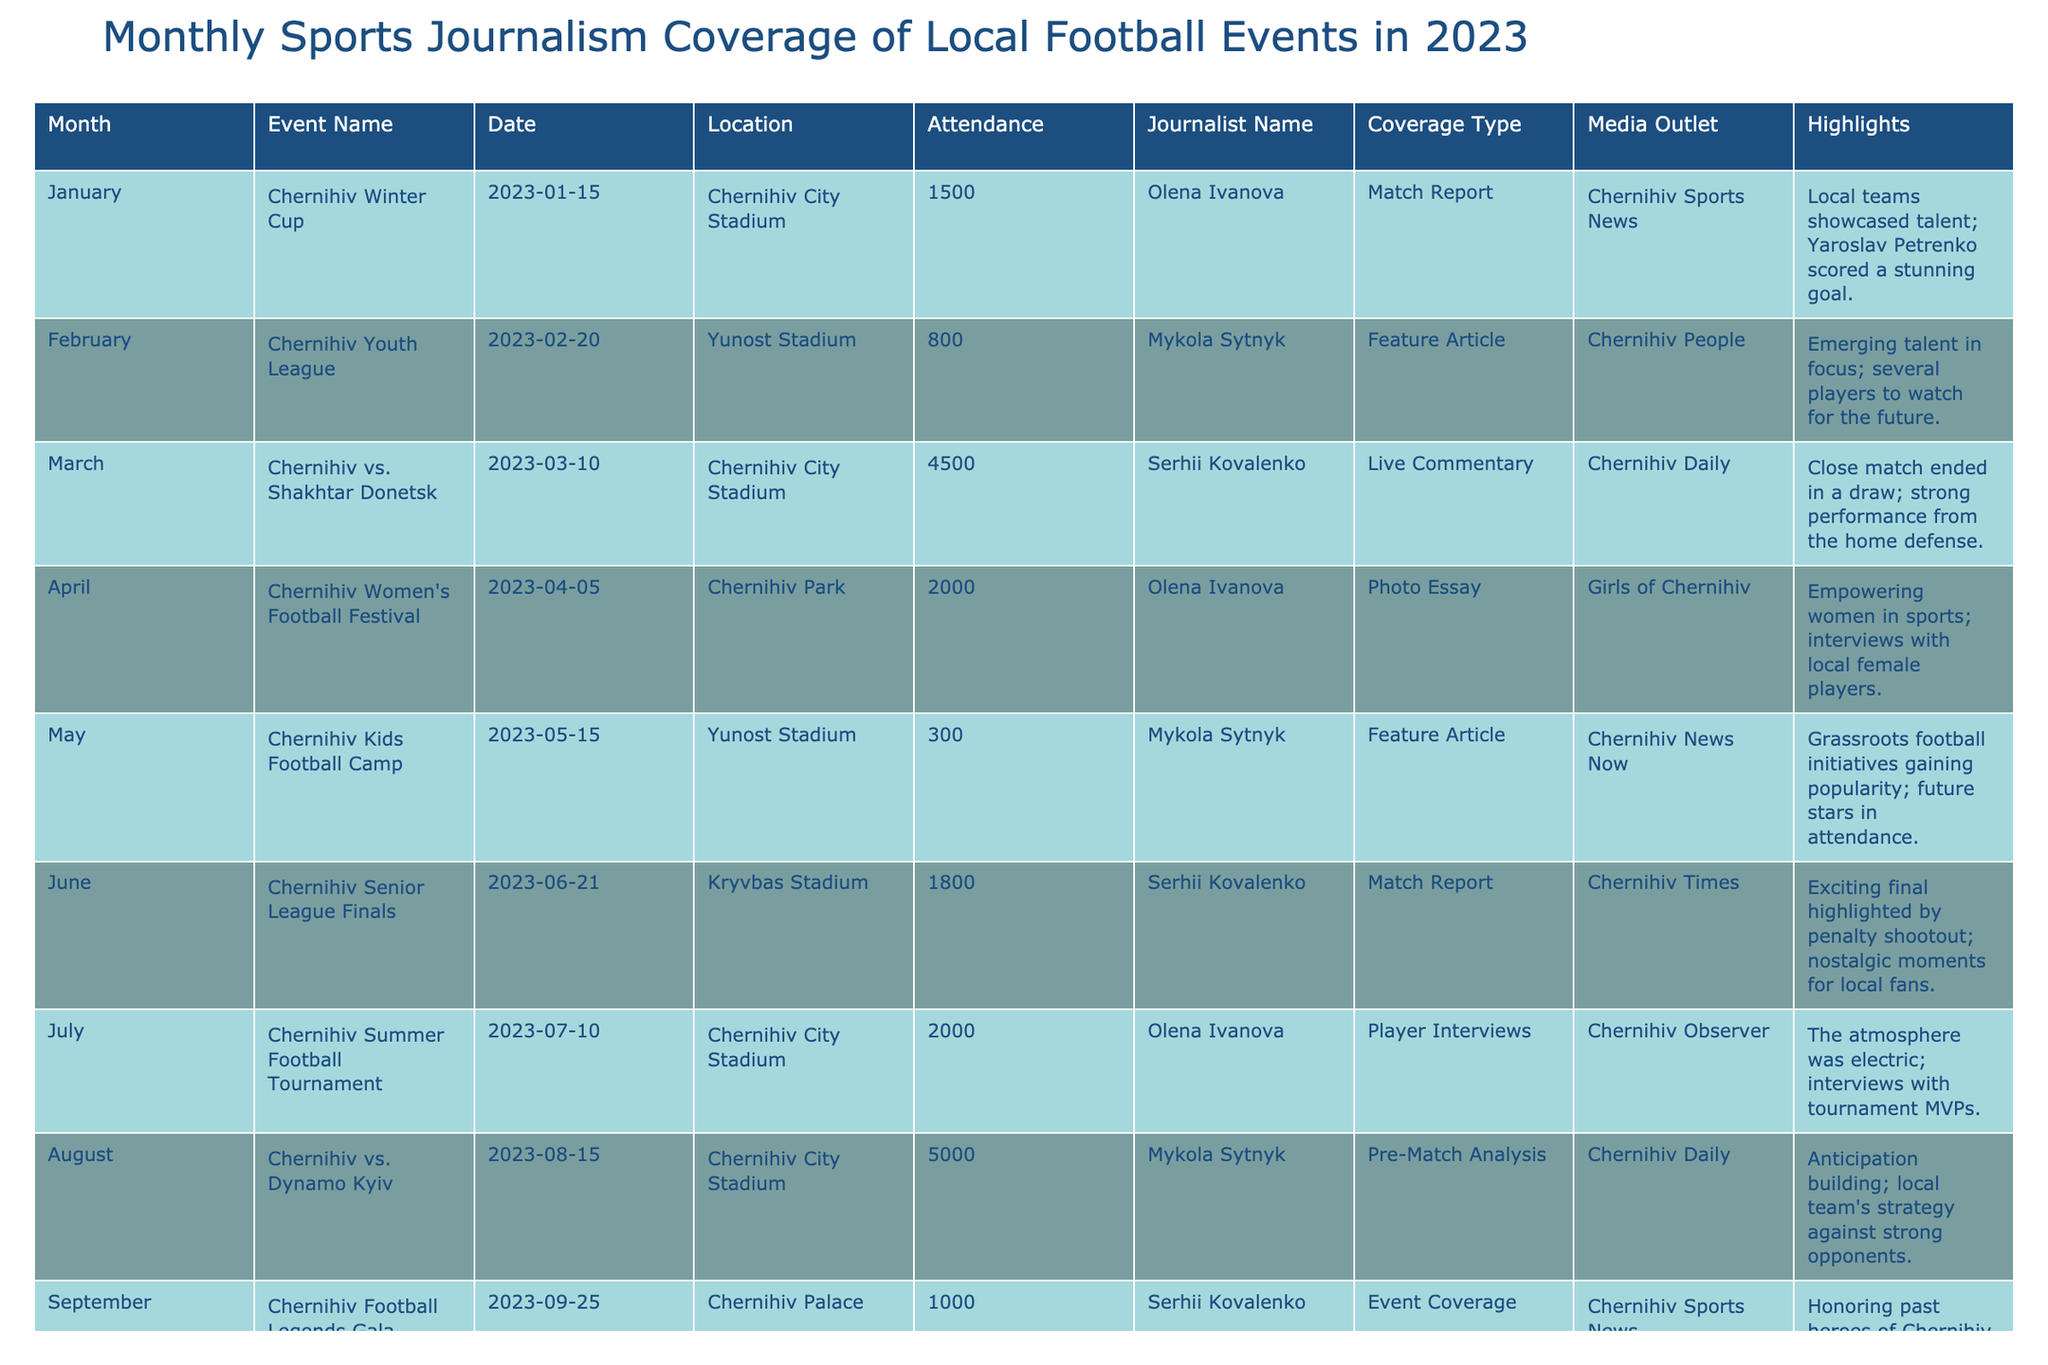What was the highest attendance recorded for a local football event in 2023? By looking at the 'Attendance' column, the highest value is 5000, which corresponds to the match between Chernihiv and Dynamo Kyiv in August.
Answer: 5000 Who wrote the feature story about the Chernihiv Football Club Charity Game? In the 'Journalist Name' column for the November entry, it shows Mykola Sytnyk wrote the feature story about the charity game.
Answer: Mykola Sytnyk How many events were covered by Olena Ivanova? By counting the entries where the 'Journalist Name' is Olena Ivanova, we find there are 4 events covered by her (January, April, July, and October).
Answer: 4 Which event took place with the lowest attendance? The 'Attendance' for the Chernihiv Kids Football Camp in May is 300, which is the lowest attendance recorded in the table.
Answer: 300 Was there any event covered by Serhii Kovalenko in June? Yes, the Chernihiv Senior League Finals in June were covered by Serhii Kovalenko.
Answer: Yes How does the total attendance of events covered by Mykola Sytnyk compare to that of Serhii Kovalenko? The total attendance for Mykola Sytnyk's events (800 + 300 + 5000 + 1200 = 6300) and for Serhii Kovalenko's events (4500 + 1800 + 1000 = 7300) indicates that Serhii Kovalenko had a higher total attendance by 1000.
Answer: Serhii Kovalenko had a higher total attendance What type of coverage was used for the Chernihiv vs. Shakhtar Donetsk match? The type of coverage for the match on March 10 was Live Commentary, as noted in the 'Coverage Type' column.
Answer: Live Commentary How many events featured a specific focus on youth or grassroots football? The events related to youth or grassroots football are the Chernihiv Youth League in February, the Kids Football Camp in May, and the Women's Football Festival in April, totaling 3 events.
Answer: 3 Was the Chernihiv Year-End Football Review covered by a local journalist? No, the entry indicates that the Year-End Football Review was not covered by any local journalist as the Journalist Name is marked as N/A.
Answer: No What was the predominant medium outlet for the reported events? In reviewing the 'Media Outlet' column, Chernihiv Sports News appeared most frequently, covering events in January and September.
Answer: Chernihiv Sports News Which month had the most events reported, and how many were there? By counting the unique month entries, we can see that no month has more than one event reported, as each month has only a single entry, making it a total of 12 unique events across 12 months.
Answer: Each month had one event 